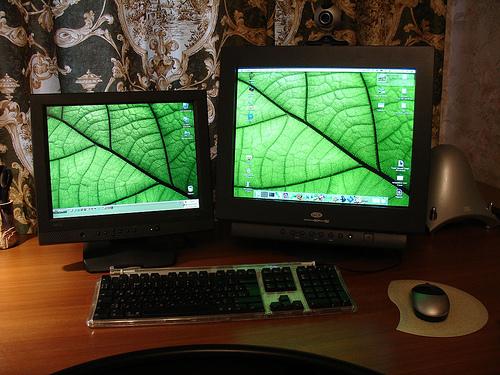Is there anything to read on the desk?
Write a very short answer. No. How many computer monitors are there?
Quick response, please. 2. Is the mouse wireless?
Be succinct. Yes. What scene is on the laptop screen?
Give a very brief answer. Leaf. What is the screen picture a close up of?
Be succinct. Leaf. Are all the computer images displaying the same thing?
Quick response, please. Yes. 